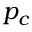Convert formula to latex. <formula><loc_0><loc_0><loc_500><loc_500>p _ { c }</formula> 